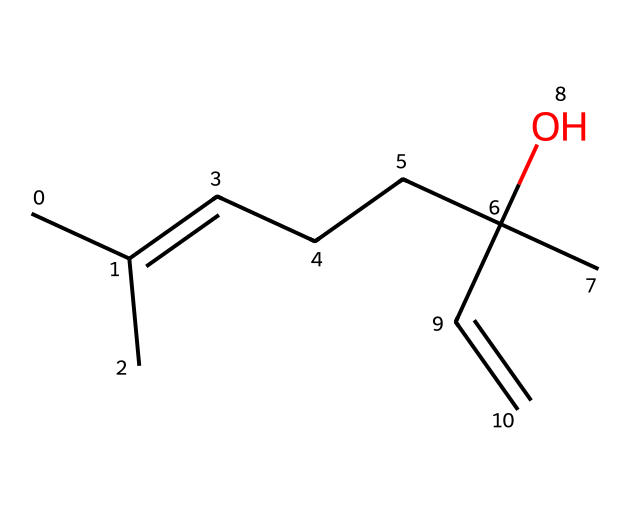What is the molecular formula of this compound? The SMILES representation indicates the presence of carbon (C), hydrogen (H), and oxygen (O) atoms. By counting the atoms represented in the structure, we can deduce the molecular formula. There are 15 carbon atoms, 28 hydrogen atoms, and 1 oxygen atom. Thus, the molecular formula is C15H28O.
Answer: C15H28O How many carbon atoms are in this compound? The SMILES structure shows 'C' for carbon and we can count how many 'C' symbols are present. In this case, there are 15 occurrences of 'C'.
Answer: 15 Is this compound an alcohol? The structure includes an -OH group (indicated by "C)(O)"), which is characteristic of alcohols, confirming that this compound is indeed an alcohol.
Answer: Yes What type of compound is this? The structure features aliphatic carbon chains and a hydroxyl group typical of terpene alcohols, indicating that it is a terpene. Terpenes are known for their aromatic properties and are common in essential oils like lavender.
Answer: Terpene Does this compound have double bonds? In the SMILES notation, the presence of "C=C" indicates that there are double bonds in the structure. This can be verified by locating those specific sections in the molecular arrangement.
Answer: Yes What is the primary function of this compound related to stress relief? The compound is known for its calming and relaxing effects, attributed to its molecular structure which allows it to interact with neuroreceptors in a way that helps promote relaxation and reduce stress.
Answer: Calming effects 